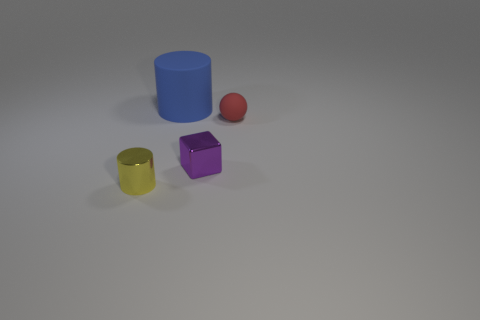Does the shiny thing that is in front of the cube have the same shape as the matte object that is left of the tiny purple cube?
Provide a short and direct response. Yes. What is the shape of the yellow object that is the same size as the purple shiny thing?
Give a very brief answer. Cylinder. How many matte objects are blocks or objects?
Offer a terse response. 2. Is the material of the tiny object that is to the left of the large object the same as the purple block that is behind the metallic cylinder?
Provide a succinct answer. Yes. What color is the sphere that is the same material as the big blue object?
Your answer should be compact. Red. Are there more rubber objects to the right of the purple block than small rubber objects in front of the red sphere?
Offer a terse response. Yes. Is there a brown metal sphere?
Keep it short and to the point. No. How many objects are small things or big metallic cylinders?
Your answer should be compact. 3. There is a small thing that is behind the block; how many large cylinders are behind it?
Make the answer very short. 1. Are there more shiny things than big brown rubber things?
Provide a short and direct response. Yes. 